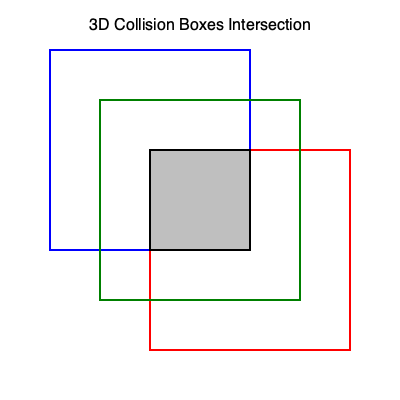In a 3D game scene, three collision boxes are represented by cubes with side lengths of 200 units each. The blue cube is positioned at (50, 50, 50), the red cube at (150, 150, 150), and the green cube at (100, 100, 100). What is the volume of the intersection of all three cubes? To find the volume of the intersection, we need to follow these steps:

1. Identify the overlapping region:
   The intersection of all three cubes will be another cube.

2. Determine the coordinates of the intersection cube:
   - X-axis: max(50, 100, 150) to min(250, 350, 300) = 150 to 250
   - Y-axis: max(50, 100, 150) to min(250, 350, 300) = 150 to 250
   - Z-axis: max(50, 100, 150) to min(250, 350, 300) = 150 to 250

3. Calculate the side length of the intersection cube:
   Side length = 250 - 150 = 100 units

4. Calculate the volume of the intersection:
   Volume = side length³
   $$V = 100³ = 1,000,000 \text{ cubic units}$$

The volume of the intersection of all three cubes is 1,000,000 cubic units.
Answer: 1,000,000 cubic units 